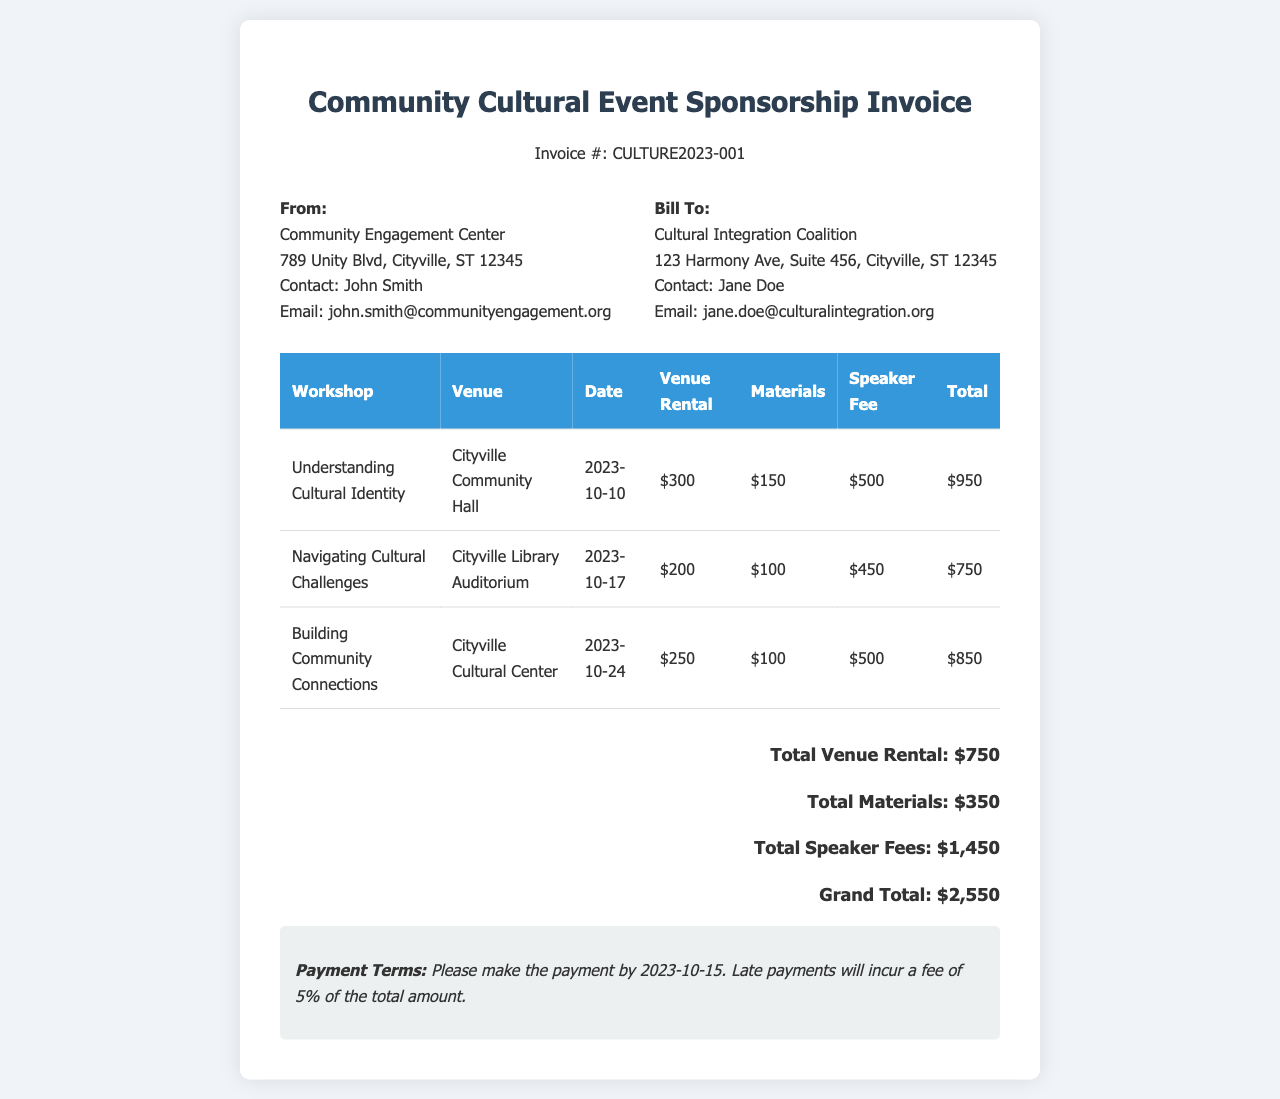What is the invoice number? The invoice number is listed in the header of the document.
Answer: CULTURE2023-001 Who is the contact person for the Cultural Integration Coalition? The contact person is provided in the "Bill To" section.
Answer: Jane Doe What is the total amount for speaker fees? The total for speaker fees is stated in the summary at the bottom of the document.
Answer: $1,450 How many workshops are included in the invoice? The number of workshops can be counted in the table provided in the document.
Answer: 3 Which venue was used for the workshop "Understanding Cultural Identity"? The table lists the venue for each workshop, including this one.
Answer: Cityville Community Hall When is the payment due? The payment terms mention the due date clearly in the document.
Answer: 2023-10-15 What is the total amount for venue rental? This total is explicitly stated in the summary section of the invoice.
Answer: $750 Which workshop has the highest total cost? The total cost for each workshop can be compared in the table to find the highest.
Answer: Understanding Cultural Identity What percentage is charged for late payments? The payment terms section outlines the fee for late payments.
Answer: 5% 